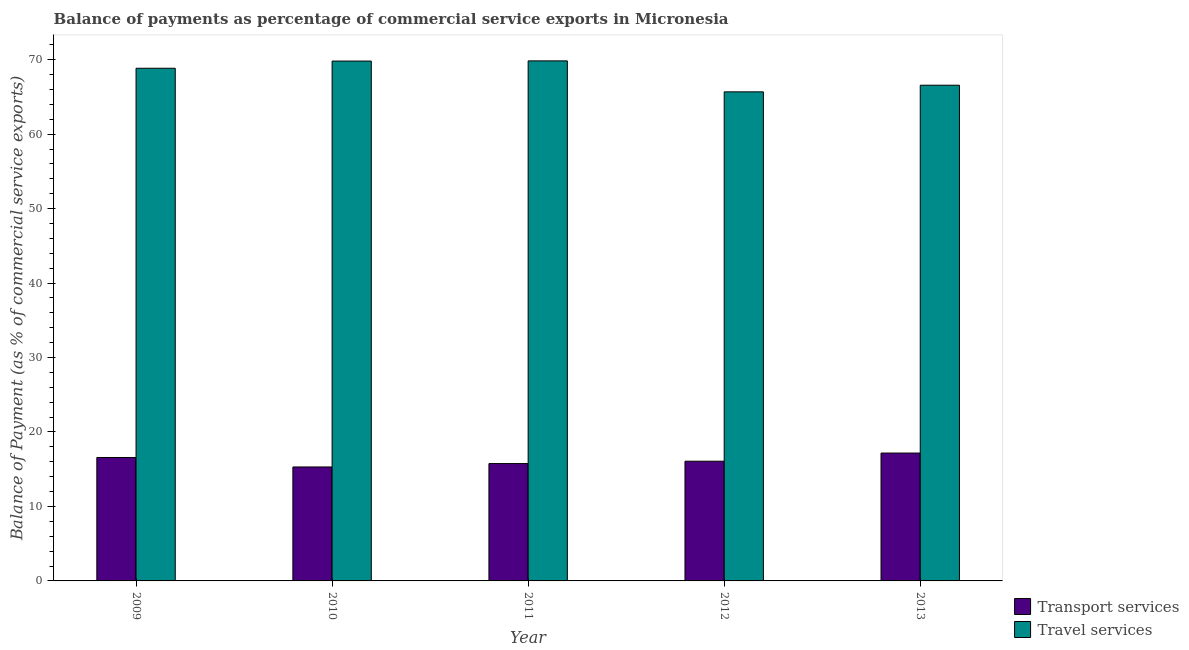How many different coloured bars are there?
Your response must be concise. 2. How many groups of bars are there?
Provide a short and direct response. 5. Are the number of bars on each tick of the X-axis equal?
Give a very brief answer. Yes. How many bars are there on the 5th tick from the left?
Provide a short and direct response. 2. What is the balance of payments of travel services in 2011?
Make the answer very short. 69.84. Across all years, what is the maximum balance of payments of travel services?
Make the answer very short. 69.84. Across all years, what is the minimum balance of payments of transport services?
Offer a very short reply. 15.3. What is the total balance of payments of travel services in the graph?
Give a very brief answer. 340.73. What is the difference between the balance of payments of transport services in 2011 and that in 2013?
Offer a terse response. -1.41. What is the difference between the balance of payments of travel services in 2010 and the balance of payments of transport services in 2009?
Provide a short and direct response. 0.97. What is the average balance of payments of transport services per year?
Your response must be concise. 16.18. In the year 2012, what is the difference between the balance of payments of transport services and balance of payments of travel services?
Make the answer very short. 0. What is the ratio of the balance of payments of travel services in 2010 to that in 2011?
Your response must be concise. 1. Is the balance of payments of travel services in 2009 less than that in 2013?
Your answer should be compact. No. What is the difference between the highest and the second highest balance of payments of travel services?
Ensure brevity in your answer.  0.03. What is the difference between the highest and the lowest balance of payments of travel services?
Offer a very short reply. 4.16. Is the sum of the balance of payments of travel services in 2009 and 2010 greater than the maximum balance of payments of transport services across all years?
Provide a succinct answer. Yes. What does the 2nd bar from the left in 2009 represents?
Ensure brevity in your answer.  Travel services. What does the 2nd bar from the right in 2011 represents?
Ensure brevity in your answer.  Transport services. How many bars are there?
Make the answer very short. 10. Are all the bars in the graph horizontal?
Provide a short and direct response. No. Does the graph contain grids?
Ensure brevity in your answer.  No. Where does the legend appear in the graph?
Provide a short and direct response. Bottom right. How are the legend labels stacked?
Provide a short and direct response. Vertical. What is the title of the graph?
Provide a succinct answer. Balance of payments as percentage of commercial service exports in Micronesia. Does "Electricity and heat production" appear as one of the legend labels in the graph?
Offer a very short reply. No. What is the label or title of the Y-axis?
Give a very brief answer. Balance of Payment (as % of commercial service exports). What is the Balance of Payment (as % of commercial service exports) in Transport services in 2009?
Make the answer very short. 16.57. What is the Balance of Payment (as % of commercial service exports) of Travel services in 2009?
Your answer should be very brief. 68.84. What is the Balance of Payment (as % of commercial service exports) in Transport services in 2010?
Make the answer very short. 15.3. What is the Balance of Payment (as % of commercial service exports) in Travel services in 2010?
Keep it short and to the point. 69.81. What is the Balance of Payment (as % of commercial service exports) in Transport services in 2011?
Offer a very short reply. 15.76. What is the Balance of Payment (as % of commercial service exports) in Travel services in 2011?
Offer a terse response. 69.84. What is the Balance of Payment (as % of commercial service exports) of Transport services in 2012?
Make the answer very short. 16.08. What is the Balance of Payment (as % of commercial service exports) in Travel services in 2012?
Give a very brief answer. 65.67. What is the Balance of Payment (as % of commercial service exports) of Transport services in 2013?
Keep it short and to the point. 17.17. What is the Balance of Payment (as % of commercial service exports) of Travel services in 2013?
Provide a short and direct response. 66.57. Across all years, what is the maximum Balance of Payment (as % of commercial service exports) of Transport services?
Provide a succinct answer. 17.17. Across all years, what is the maximum Balance of Payment (as % of commercial service exports) of Travel services?
Offer a very short reply. 69.84. Across all years, what is the minimum Balance of Payment (as % of commercial service exports) in Transport services?
Ensure brevity in your answer.  15.3. Across all years, what is the minimum Balance of Payment (as % of commercial service exports) in Travel services?
Ensure brevity in your answer.  65.67. What is the total Balance of Payment (as % of commercial service exports) of Transport services in the graph?
Offer a very short reply. 80.88. What is the total Balance of Payment (as % of commercial service exports) in Travel services in the graph?
Give a very brief answer. 340.73. What is the difference between the Balance of Payment (as % of commercial service exports) of Transport services in 2009 and that in 2010?
Keep it short and to the point. 1.27. What is the difference between the Balance of Payment (as % of commercial service exports) in Travel services in 2009 and that in 2010?
Your response must be concise. -0.97. What is the difference between the Balance of Payment (as % of commercial service exports) in Transport services in 2009 and that in 2011?
Offer a terse response. 0.82. What is the difference between the Balance of Payment (as % of commercial service exports) of Travel services in 2009 and that in 2011?
Provide a short and direct response. -0.99. What is the difference between the Balance of Payment (as % of commercial service exports) in Transport services in 2009 and that in 2012?
Your answer should be very brief. 0.5. What is the difference between the Balance of Payment (as % of commercial service exports) in Travel services in 2009 and that in 2012?
Ensure brevity in your answer.  3.17. What is the difference between the Balance of Payment (as % of commercial service exports) of Transport services in 2009 and that in 2013?
Make the answer very short. -0.6. What is the difference between the Balance of Payment (as % of commercial service exports) of Travel services in 2009 and that in 2013?
Your response must be concise. 2.28. What is the difference between the Balance of Payment (as % of commercial service exports) in Transport services in 2010 and that in 2011?
Offer a very short reply. -0.46. What is the difference between the Balance of Payment (as % of commercial service exports) of Travel services in 2010 and that in 2011?
Ensure brevity in your answer.  -0.03. What is the difference between the Balance of Payment (as % of commercial service exports) of Transport services in 2010 and that in 2012?
Give a very brief answer. -0.77. What is the difference between the Balance of Payment (as % of commercial service exports) in Travel services in 2010 and that in 2012?
Provide a succinct answer. 4.13. What is the difference between the Balance of Payment (as % of commercial service exports) in Transport services in 2010 and that in 2013?
Make the answer very short. -1.87. What is the difference between the Balance of Payment (as % of commercial service exports) in Travel services in 2010 and that in 2013?
Offer a very short reply. 3.24. What is the difference between the Balance of Payment (as % of commercial service exports) of Transport services in 2011 and that in 2012?
Provide a short and direct response. -0.32. What is the difference between the Balance of Payment (as % of commercial service exports) of Travel services in 2011 and that in 2012?
Ensure brevity in your answer.  4.16. What is the difference between the Balance of Payment (as % of commercial service exports) of Transport services in 2011 and that in 2013?
Your answer should be compact. -1.41. What is the difference between the Balance of Payment (as % of commercial service exports) in Travel services in 2011 and that in 2013?
Your response must be concise. 3.27. What is the difference between the Balance of Payment (as % of commercial service exports) of Transport services in 2012 and that in 2013?
Provide a succinct answer. -1.09. What is the difference between the Balance of Payment (as % of commercial service exports) in Travel services in 2012 and that in 2013?
Your answer should be very brief. -0.89. What is the difference between the Balance of Payment (as % of commercial service exports) of Transport services in 2009 and the Balance of Payment (as % of commercial service exports) of Travel services in 2010?
Give a very brief answer. -53.24. What is the difference between the Balance of Payment (as % of commercial service exports) of Transport services in 2009 and the Balance of Payment (as % of commercial service exports) of Travel services in 2011?
Provide a short and direct response. -53.26. What is the difference between the Balance of Payment (as % of commercial service exports) of Transport services in 2009 and the Balance of Payment (as % of commercial service exports) of Travel services in 2012?
Ensure brevity in your answer.  -49.1. What is the difference between the Balance of Payment (as % of commercial service exports) in Transport services in 2009 and the Balance of Payment (as % of commercial service exports) in Travel services in 2013?
Offer a very short reply. -49.99. What is the difference between the Balance of Payment (as % of commercial service exports) of Transport services in 2010 and the Balance of Payment (as % of commercial service exports) of Travel services in 2011?
Your response must be concise. -54.53. What is the difference between the Balance of Payment (as % of commercial service exports) of Transport services in 2010 and the Balance of Payment (as % of commercial service exports) of Travel services in 2012?
Your answer should be compact. -50.37. What is the difference between the Balance of Payment (as % of commercial service exports) in Transport services in 2010 and the Balance of Payment (as % of commercial service exports) in Travel services in 2013?
Ensure brevity in your answer.  -51.26. What is the difference between the Balance of Payment (as % of commercial service exports) in Transport services in 2011 and the Balance of Payment (as % of commercial service exports) in Travel services in 2012?
Your answer should be compact. -49.92. What is the difference between the Balance of Payment (as % of commercial service exports) of Transport services in 2011 and the Balance of Payment (as % of commercial service exports) of Travel services in 2013?
Provide a short and direct response. -50.81. What is the difference between the Balance of Payment (as % of commercial service exports) of Transport services in 2012 and the Balance of Payment (as % of commercial service exports) of Travel services in 2013?
Make the answer very short. -50.49. What is the average Balance of Payment (as % of commercial service exports) of Transport services per year?
Your answer should be very brief. 16.18. What is the average Balance of Payment (as % of commercial service exports) in Travel services per year?
Provide a short and direct response. 68.15. In the year 2009, what is the difference between the Balance of Payment (as % of commercial service exports) of Transport services and Balance of Payment (as % of commercial service exports) of Travel services?
Your response must be concise. -52.27. In the year 2010, what is the difference between the Balance of Payment (as % of commercial service exports) in Transport services and Balance of Payment (as % of commercial service exports) in Travel services?
Provide a succinct answer. -54.51. In the year 2011, what is the difference between the Balance of Payment (as % of commercial service exports) in Transport services and Balance of Payment (as % of commercial service exports) in Travel services?
Give a very brief answer. -54.08. In the year 2012, what is the difference between the Balance of Payment (as % of commercial service exports) in Transport services and Balance of Payment (as % of commercial service exports) in Travel services?
Provide a short and direct response. -49.6. In the year 2013, what is the difference between the Balance of Payment (as % of commercial service exports) in Transport services and Balance of Payment (as % of commercial service exports) in Travel services?
Give a very brief answer. -49.4. What is the ratio of the Balance of Payment (as % of commercial service exports) of Transport services in 2009 to that in 2010?
Provide a short and direct response. 1.08. What is the ratio of the Balance of Payment (as % of commercial service exports) of Travel services in 2009 to that in 2010?
Offer a very short reply. 0.99. What is the ratio of the Balance of Payment (as % of commercial service exports) in Transport services in 2009 to that in 2011?
Provide a short and direct response. 1.05. What is the ratio of the Balance of Payment (as % of commercial service exports) in Travel services in 2009 to that in 2011?
Offer a terse response. 0.99. What is the ratio of the Balance of Payment (as % of commercial service exports) in Transport services in 2009 to that in 2012?
Your answer should be very brief. 1.03. What is the ratio of the Balance of Payment (as % of commercial service exports) of Travel services in 2009 to that in 2012?
Your answer should be compact. 1.05. What is the ratio of the Balance of Payment (as % of commercial service exports) in Transport services in 2009 to that in 2013?
Provide a short and direct response. 0.97. What is the ratio of the Balance of Payment (as % of commercial service exports) of Travel services in 2009 to that in 2013?
Offer a terse response. 1.03. What is the ratio of the Balance of Payment (as % of commercial service exports) in Transport services in 2010 to that in 2011?
Your answer should be very brief. 0.97. What is the ratio of the Balance of Payment (as % of commercial service exports) in Travel services in 2010 to that in 2011?
Provide a succinct answer. 1. What is the ratio of the Balance of Payment (as % of commercial service exports) of Transport services in 2010 to that in 2012?
Provide a succinct answer. 0.95. What is the ratio of the Balance of Payment (as % of commercial service exports) of Travel services in 2010 to that in 2012?
Keep it short and to the point. 1.06. What is the ratio of the Balance of Payment (as % of commercial service exports) in Transport services in 2010 to that in 2013?
Provide a short and direct response. 0.89. What is the ratio of the Balance of Payment (as % of commercial service exports) in Travel services in 2010 to that in 2013?
Provide a short and direct response. 1.05. What is the ratio of the Balance of Payment (as % of commercial service exports) in Transport services in 2011 to that in 2012?
Your answer should be very brief. 0.98. What is the ratio of the Balance of Payment (as % of commercial service exports) of Travel services in 2011 to that in 2012?
Your answer should be compact. 1.06. What is the ratio of the Balance of Payment (as % of commercial service exports) in Transport services in 2011 to that in 2013?
Your response must be concise. 0.92. What is the ratio of the Balance of Payment (as % of commercial service exports) of Travel services in 2011 to that in 2013?
Your response must be concise. 1.05. What is the ratio of the Balance of Payment (as % of commercial service exports) in Transport services in 2012 to that in 2013?
Your response must be concise. 0.94. What is the ratio of the Balance of Payment (as % of commercial service exports) of Travel services in 2012 to that in 2013?
Your answer should be very brief. 0.99. What is the difference between the highest and the second highest Balance of Payment (as % of commercial service exports) of Transport services?
Provide a succinct answer. 0.6. What is the difference between the highest and the second highest Balance of Payment (as % of commercial service exports) of Travel services?
Make the answer very short. 0.03. What is the difference between the highest and the lowest Balance of Payment (as % of commercial service exports) of Transport services?
Ensure brevity in your answer.  1.87. What is the difference between the highest and the lowest Balance of Payment (as % of commercial service exports) of Travel services?
Make the answer very short. 4.16. 